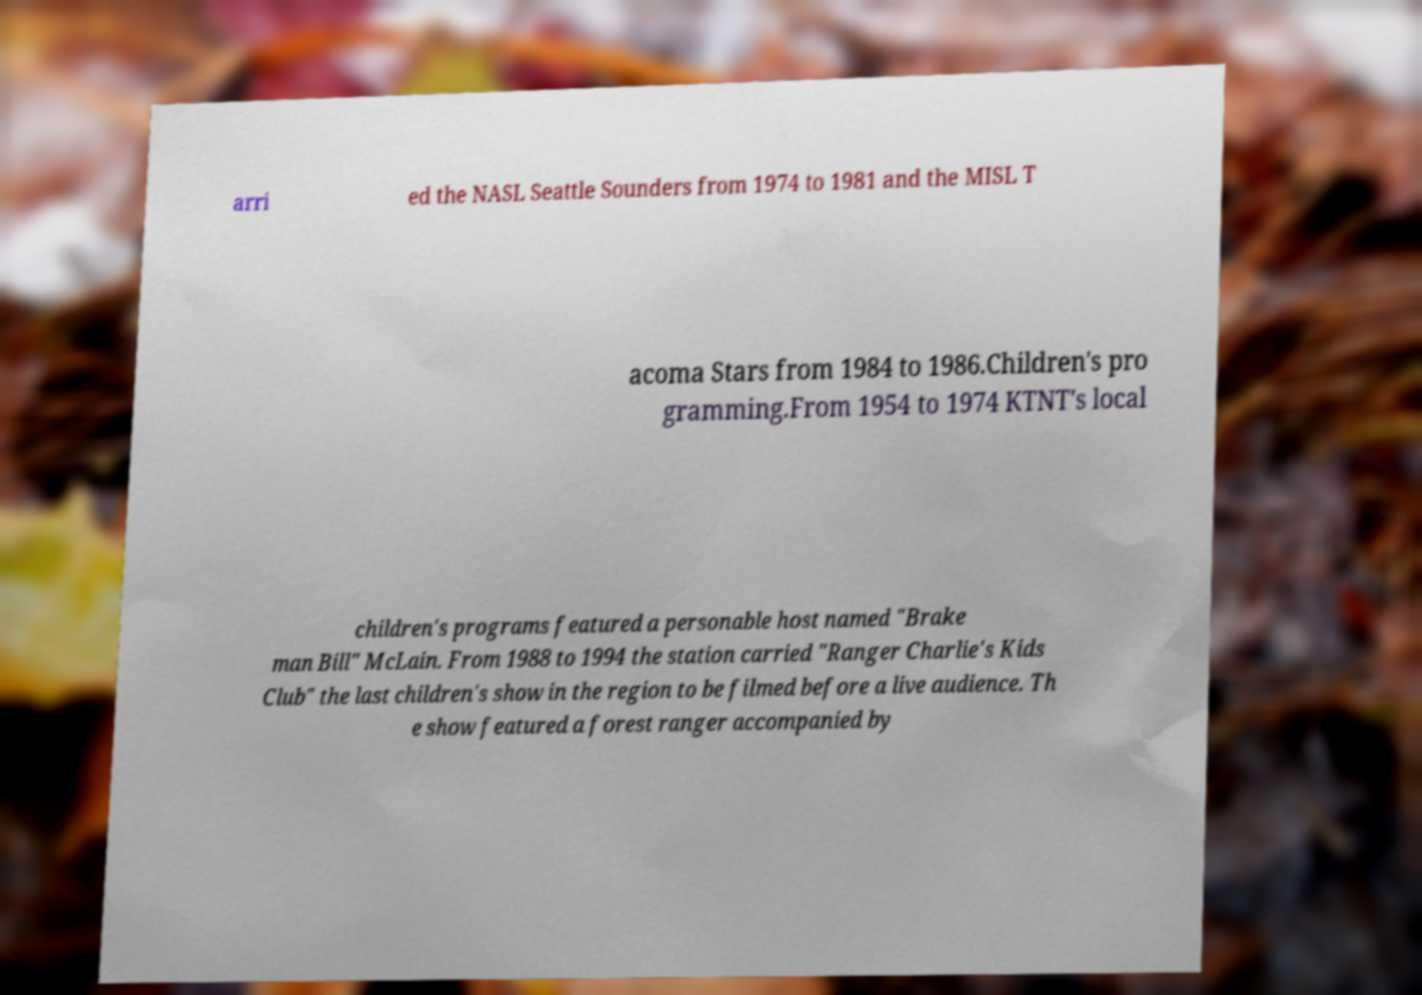Can you accurately transcribe the text from the provided image for me? arri ed the NASL Seattle Sounders from 1974 to 1981 and the MISL T acoma Stars from 1984 to 1986.Children's pro gramming.From 1954 to 1974 KTNT's local children's programs featured a personable host named "Brake man Bill" McLain. From 1988 to 1994 the station carried "Ranger Charlie's Kids Club" the last children's show in the region to be filmed before a live audience. Th e show featured a forest ranger accompanied by 